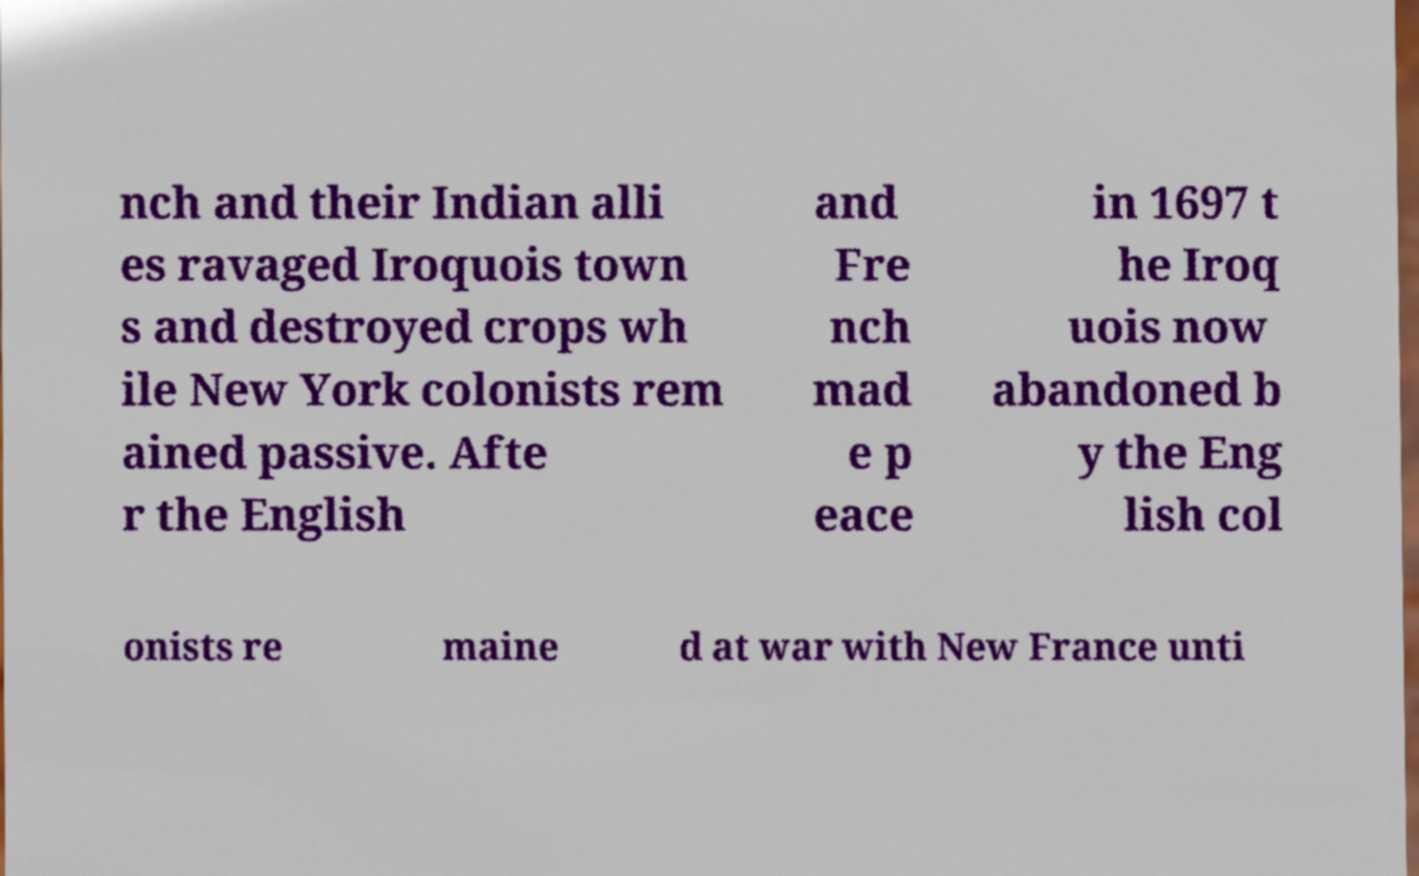Can you accurately transcribe the text from the provided image for me? nch and their Indian alli es ravaged Iroquois town s and destroyed crops wh ile New York colonists rem ained passive. Afte r the English and Fre nch mad e p eace in 1697 t he Iroq uois now abandoned b y the Eng lish col onists re maine d at war with New France unti 